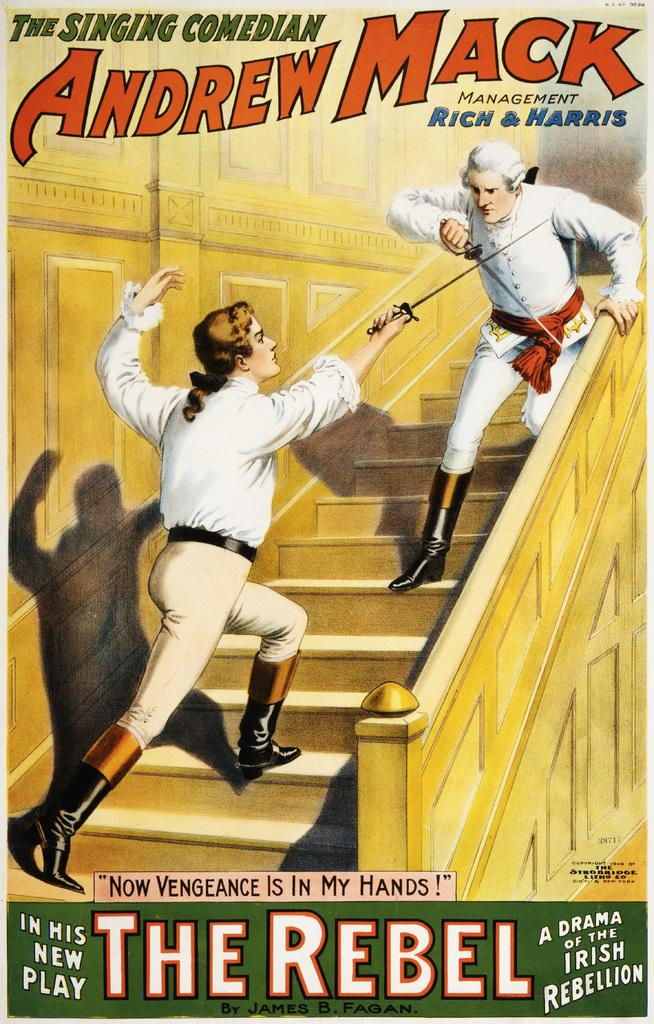Provide a one-sentence caption for the provided image. An advertisement for an old play THE SINGING COMEDIAN ANDREW MACK MANAGEMENT RICH & HARRIS, with THE REBEL at the bottom of the ad. 